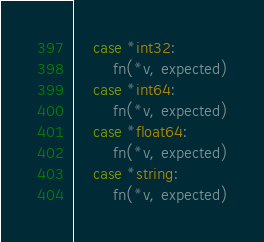Convert code to text. <code><loc_0><loc_0><loc_500><loc_500><_Go_>	case *int32:
		fn(*v, expected)
	case *int64:
		fn(*v, expected)
	case *float64:
		fn(*v, expected)
	case *string:
		fn(*v, expected)</code> 